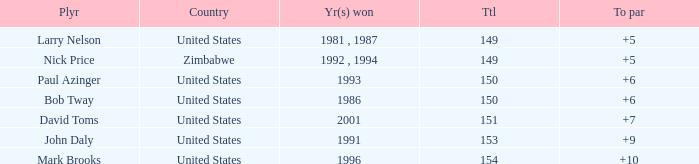What is Zimbabwe's total with a to par higher than 5? None. 